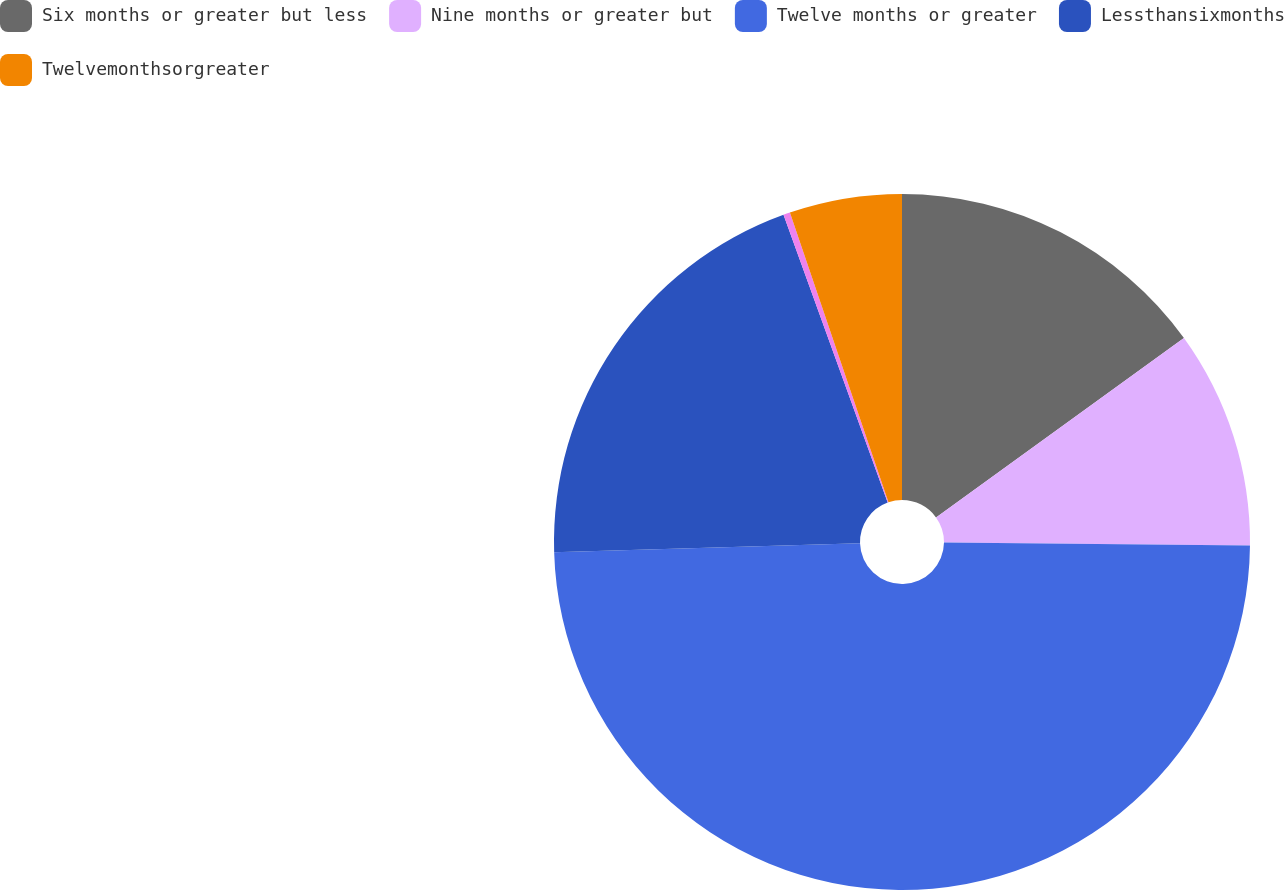<chart> <loc_0><loc_0><loc_500><loc_500><pie_chart><fcel>Six months or greater but less<fcel>Nine months or greater but<fcel>Twelve months or greater<fcel>Lessthansixmonths<fcel>Unnamed: 4<fcel>Twelvemonthsorgreater<nl><fcel>15.03%<fcel>10.13%<fcel>49.37%<fcel>19.94%<fcel>0.31%<fcel>5.22%<nl></chart> 